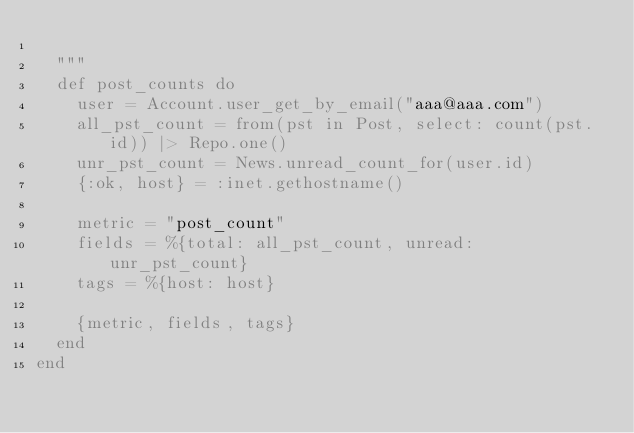Convert code to text. <code><loc_0><loc_0><loc_500><loc_500><_Elixir_>
  """
  def post_counts do
    user = Account.user_get_by_email("aaa@aaa.com")
    all_pst_count = from(pst in Post, select: count(pst.id)) |> Repo.one()
    unr_pst_count = News.unread_count_for(user.id)
    {:ok, host} = :inet.gethostname()

    metric = "post_count"
    fields = %{total: all_pst_count, unread: unr_pst_count}
    tags = %{host: host}

    {metric, fields, tags}
  end
end
</code> 